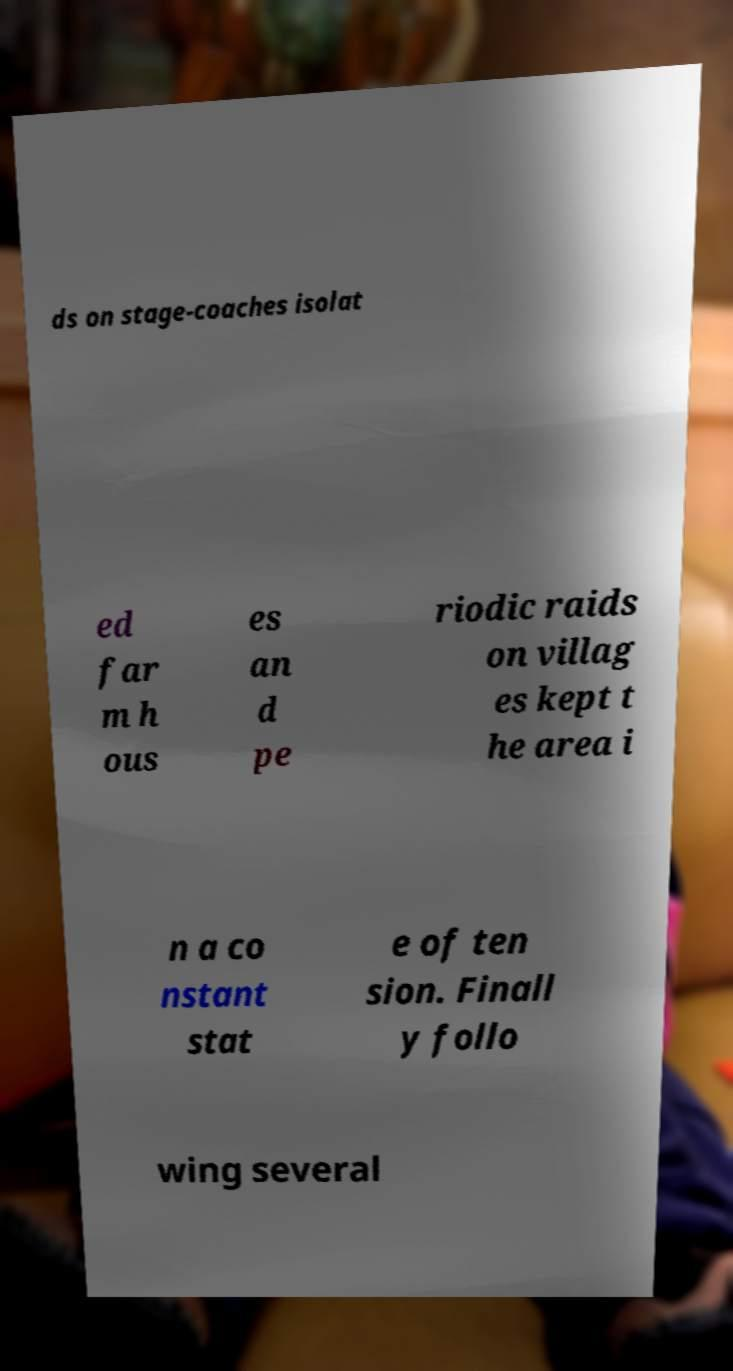There's text embedded in this image that I need extracted. Can you transcribe it verbatim? ds on stage-coaches isolat ed far m h ous es an d pe riodic raids on villag es kept t he area i n a co nstant stat e of ten sion. Finall y follo wing several 